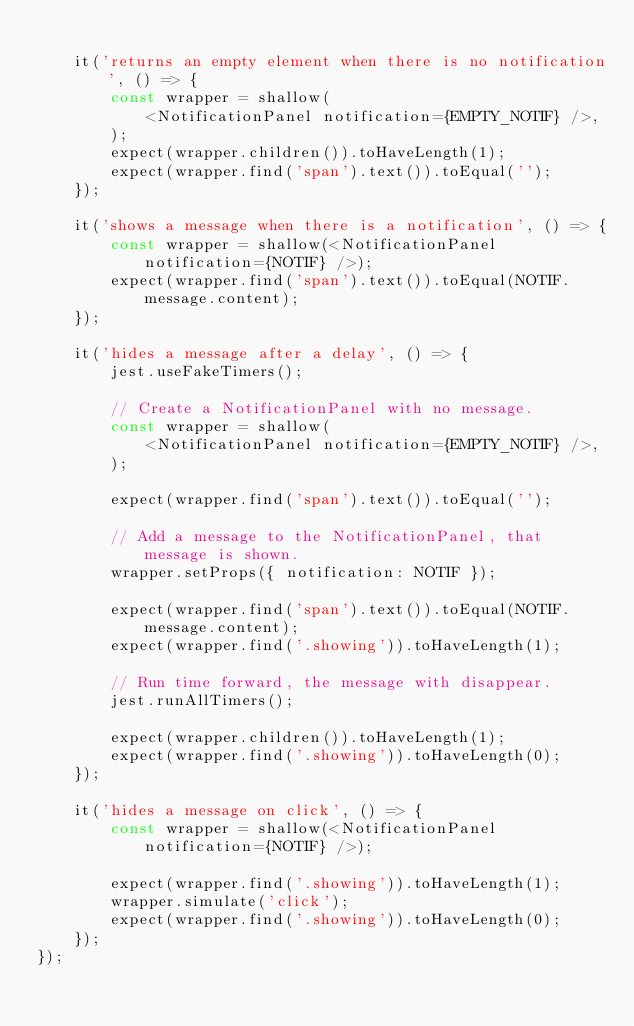<code> <loc_0><loc_0><loc_500><loc_500><_JavaScript_>
    it('returns an empty element when there is no notification', () => {
        const wrapper = shallow(
            <NotificationPanel notification={EMPTY_NOTIF} />,
        );
        expect(wrapper.children()).toHaveLength(1);
        expect(wrapper.find('span').text()).toEqual('');
    });

    it('shows a message when there is a notification', () => {
        const wrapper = shallow(<NotificationPanel notification={NOTIF} />);
        expect(wrapper.find('span').text()).toEqual(NOTIF.message.content);
    });

    it('hides a message after a delay', () => {
        jest.useFakeTimers();

        // Create a NotificationPanel with no message.
        const wrapper = shallow(
            <NotificationPanel notification={EMPTY_NOTIF} />,
        );

        expect(wrapper.find('span').text()).toEqual('');

        // Add a message to the NotificationPanel, that message is shown.
        wrapper.setProps({ notification: NOTIF });

        expect(wrapper.find('span').text()).toEqual(NOTIF.message.content);
        expect(wrapper.find('.showing')).toHaveLength(1);

        // Run time forward, the message with disappear.
        jest.runAllTimers();

        expect(wrapper.children()).toHaveLength(1);
        expect(wrapper.find('.showing')).toHaveLength(0);
    });

    it('hides a message on click', () => {
        const wrapper = shallow(<NotificationPanel notification={NOTIF} />);

        expect(wrapper.find('.showing')).toHaveLength(1);
        wrapper.simulate('click');
        expect(wrapper.find('.showing')).toHaveLength(0);
    });
});
</code> 